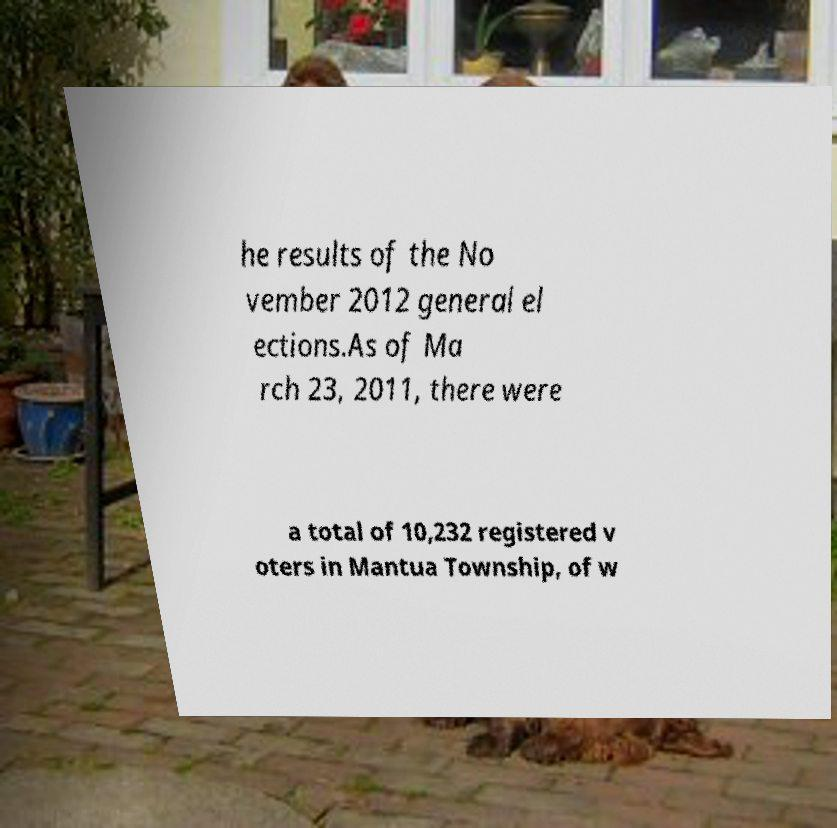Could you assist in decoding the text presented in this image and type it out clearly? he results of the No vember 2012 general el ections.As of Ma rch 23, 2011, there were a total of 10,232 registered v oters in Mantua Township, of w 